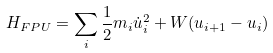Convert formula to latex. <formula><loc_0><loc_0><loc_500><loc_500>H _ { F P U } = \sum _ { i } \frac { 1 } { 2 } m _ { i } \dot { u } _ { i } ^ { 2 } + W ( u _ { i + 1 } - u _ { i } )</formula> 